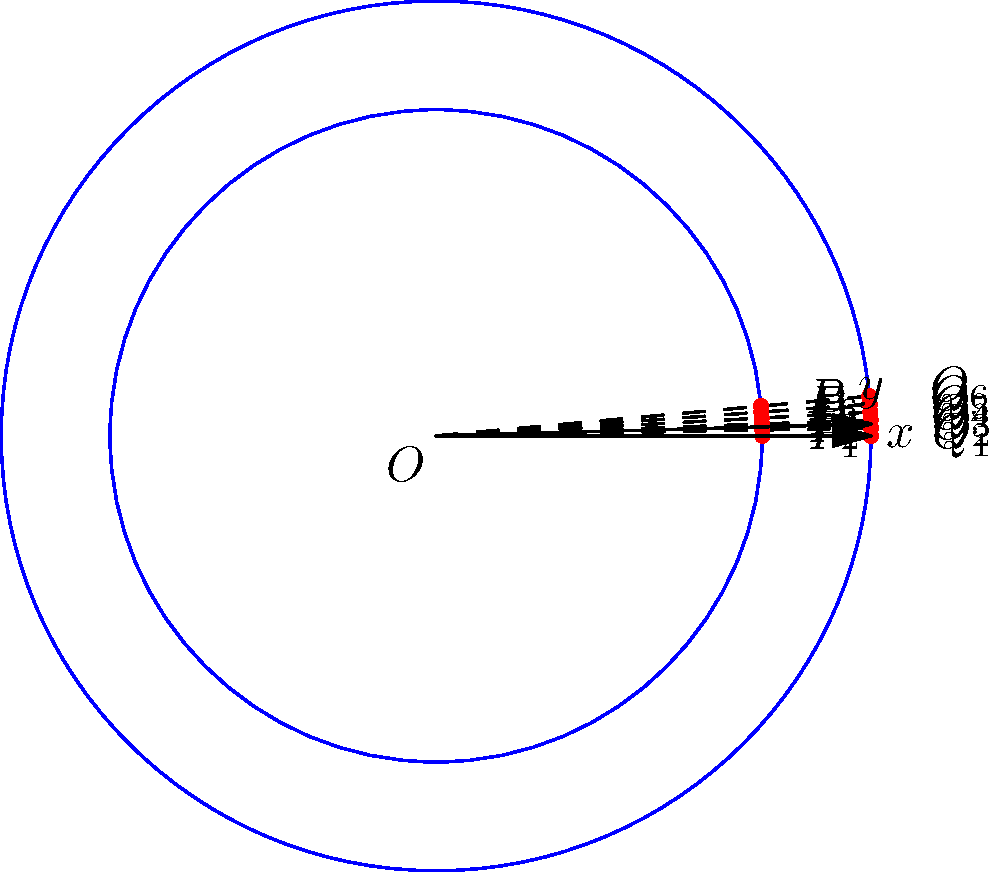You're planning a circular cannabis garden with two concentric rings. The inner ring has a radius of 3 meters, and the outer ring has a radius of 4 meters. You want to place plants evenly around each ring, with the same number of plants on both rings. If you need to maximize space efficiency while ensuring each plant has at least 1.5 meters of arc length between adjacent plants on the same ring, what is the maximum number of plants you can place on each ring? Express your final answer in polar coordinates for both rings, giving the r and θ values for each plant position. Let's approach this step-by-step:

1) First, we need to calculate the circumference of each ring:
   Inner ring: $C_1 = 2\pi r_1 = 2\pi(3) \approx 18.85$ meters
   Outer ring: $C_2 = 2\pi r_2 = 2\pi(4) \approx 25.13$ meters

2) Given that each plant needs at least 1.5 meters of arc length, we can calculate the maximum number of plants for each ring:
   Inner ring: $18.85 / 1.5 \approx 12.57$
   Outer ring: $25.13 / 1.5 \approx 16.75$

3) Since we need the same number of plants on both rings, and we're looking for the maximum, we round down to 12 plants per ring.

4) To express the positions in polar coordinates, we need to calculate the angle between each plant. For 12 plants, the angle is:
   $\theta = 360° / 12 = 30°$ or $\pi/6$ radians

5) Now we can express the positions of the plants in polar coordinates:

   Inner ring (r = 3 m):
   $P_1(3, 0), P_2(3, \pi/6), P_3(3, \pi/3), P_4(3, \pi/2), P_5(3, 2\pi/3), P_6(3, 5\pi/6),$
   $P_7(3, \pi), P_8(3, 7\pi/6), P_9(3, 4\pi/3), P_{10}(3, 3\pi/2), P_{11}(3, 5\pi/3), P_{12}(3, 11\pi/6)$

   Outer ring (r = 4 m):
   $Q_1(4, 0), Q_2(4, \pi/6), Q_3(4, \pi/3), Q_4(4, \pi/2), Q_5(4, 2\pi/3), Q_6(4, 5\pi/6),$
   $Q_7(4, \pi), Q_8(4, 7\pi/6), Q_9(4, 4\pi/3), Q_{10}(4, 3\pi/2), Q_{11}(4, 5\pi/3), Q_{12}(4, 11\pi/6)$
Answer: 12 plants per ring. Inner ring: $P_k(3, (k-1)\pi/6)$, Outer ring: $Q_k(4, (k-1)\pi/6)$, where $k = 1, 2, ..., 12$. 